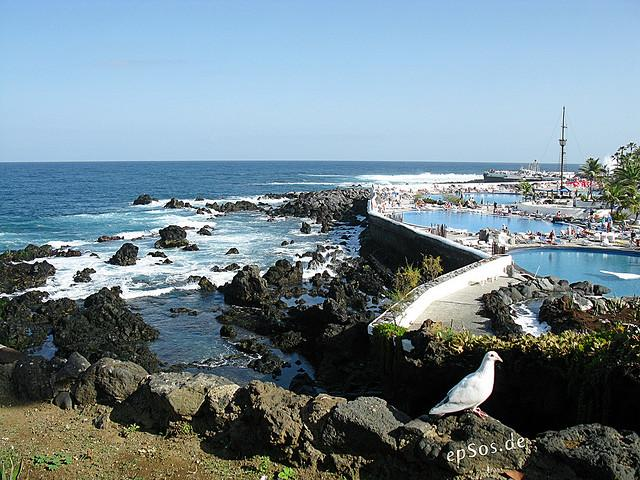What venue is shown on the right?

Choices:
A) resort area
B) water park
C) beach
D) reservoir resort area 